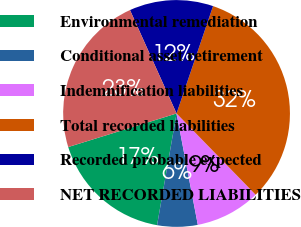Convert chart. <chart><loc_0><loc_0><loc_500><loc_500><pie_chart><fcel>Environmental remediation<fcel>Conditional asset retirement<fcel>Indemnification liabilities<fcel>Total recorded liabilities<fcel>Recorded probable expected<fcel>NET RECORDED LIABILITIES<nl><fcel>17.47%<fcel>5.75%<fcel>9.28%<fcel>32.5%<fcel>11.95%<fcel>23.05%<nl></chart> 